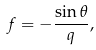<formula> <loc_0><loc_0><loc_500><loc_500>f = - \frac { \sin \theta } q ,</formula> 